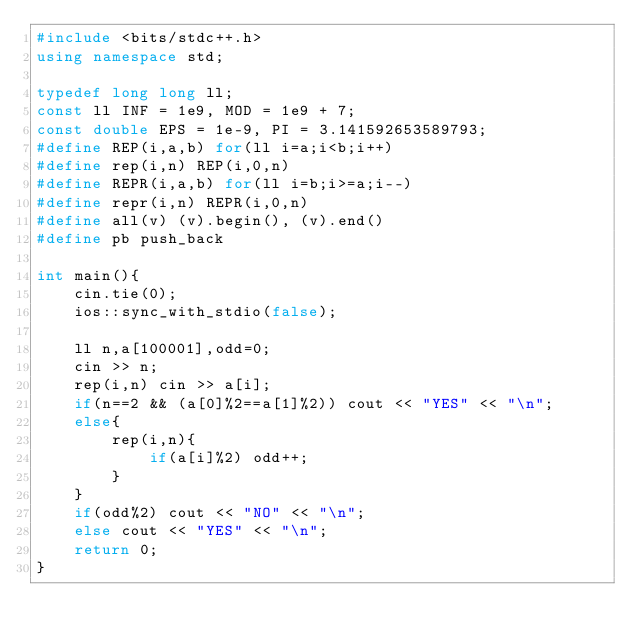Convert code to text. <code><loc_0><loc_0><loc_500><loc_500><_C++_>#include <bits/stdc++.h>
using namespace std;

typedef long long ll;
const ll INF = 1e9, MOD = 1e9 + 7;
const double EPS = 1e-9, PI = 3.141592653589793;
#define REP(i,a,b) for(ll i=a;i<b;i++)
#define rep(i,n) REP(i,0,n)
#define REPR(i,a,b) for(ll i=b;i>=a;i--)
#define repr(i,n) REPR(i,0,n)
#define all(v) (v).begin(), (v).end()
#define pb push_back

int main(){
    cin.tie(0);
    ios::sync_with_stdio(false);

    ll n,a[100001],odd=0;
    cin >> n;
    rep(i,n) cin >> a[i];
    if(n==2 && (a[0]%2==a[1]%2)) cout << "YES" << "\n";
    else{
        rep(i,n){
            if(a[i]%2) odd++;
        }
    }
    if(odd%2) cout << "NO" << "\n";
    else cout << "YES" << "\n";
    return 0;
}</code> 